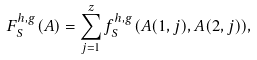Convert formula to latex. <formula><loc_0><loc_0><loc_500><loc_500>F _ { S } ^ { h , g } ( A ) = \sum _ { j = 1 } ^ { z } f _ { S } ^ { h , g } ( A ( 1 , j ) , A ( 2 , j ) ) ,</formula> 